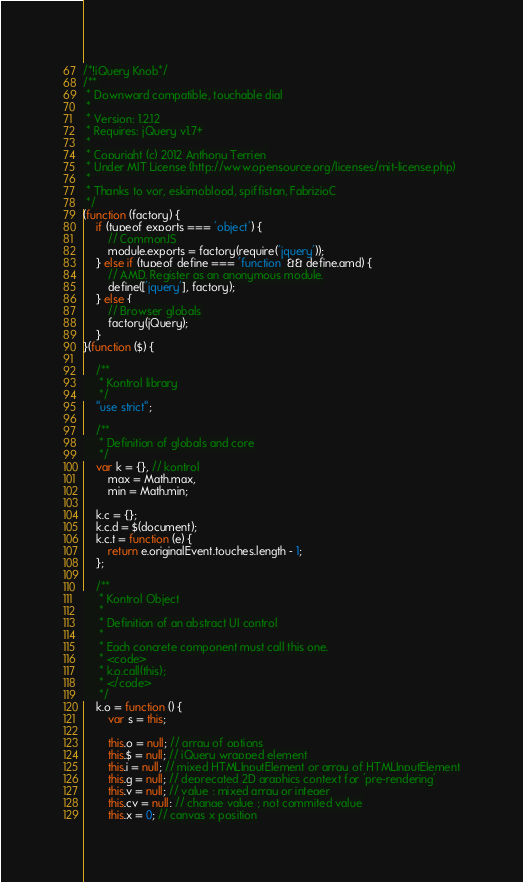Convert code to text. <code><loc_0><loc_0><loc_500><loc_500><_JavaScript_>/*!jQuery Knob*/
/**
 * Downward compatible, touchable dial
 *
 * Version: 1.2.12
 * Requires: jQuery v1.7+
 *
 * Copyright (c) 2012 Anthony Terrien
 * Under MIT License (http://www.opensource.org/licenses/mit-license.php)
 *
 * Thanks to vor, eskimoblood, spiffistan, FabrizioC
 */
(function (factory) {
    if (typeof exports === 'object') {
        // CommonJS
        module.exports = factory(require('jquery'));
    } else if (typeof define === 'function' && define.amd) {
        // AMD. Register as an anonymous module.
        define(['jquery'], factory);
    } else {
        // Browser globals
        factory(jQuery);
    }
}(function ($) {

    /**
     * Kontrol library
     */
    "use strict";

    /**
     * Definition of globals and core
     */
    var k = {}, // kontrol
        max = Math.max,
        min = Math.min;

    k.c = {};
    k.c.d = $(document);
    k.c.t = function (e) {
        return e.originalEvent.touches.length - 1;
    };

    /**
     * Kontrol Object
     *
     * Definition of an abstract UI control
     *
     * Each concrete component must call this one.
     * <code>
     * k.o.call(this);
     * </code>
     */
    k.o = function () {
        var s = this;

        this.o = null; // array of options
        this.$ = null; // jQuery wrapped element
        this.i = null; // mixed HTMLInputElement or array of HTMLInputElement
        this.g = null; // deprecated 2D graphics context for 'pre-rendering'
        this.v = null; // value ; mixed array or integer
        this.cv = null; // change value ; not commited value
        this.x = 0; // canvas x position</code> 